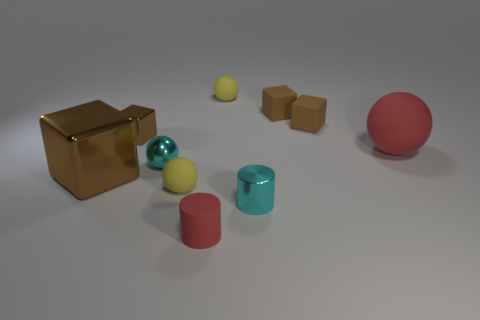There is another cylinder that is the same size as the shiny cylinder; what material is it?
Make the answer very short. Rubber. The large thing that is right of the cyan cylinder that is on the right side of the metallic ball is what color?
Ensure brevity in your answer.  Red. There is a large red sphere; what number of tiny red things are to the right of it?
Ensure brevity in your answer.  0. The matte cylinder has what color?
Offer a terse response. Red. What number of small objects are either cyan spheres or matte cubes?
Ensure brevity in your answer.  3. Does the big thing in front of the cyan sphere have the same color as the large thing that is behind the tiny shiny ball?
Make the answer very short. No. How many other objects are there of the same color as the metallic cylinder?
Give a very brief answer. 1. There is a small yellow thing that is behind the cyan sphere; what is its shape?
Provide a short and direct response. Sphere. Are there fewer yellow matte objects than brown things?
Ensure brevity in your answer.  Yes. Is the ball that is behind the tiny metallic block made of the same material as the red cylinder?
Your response must be concise. Yes. 